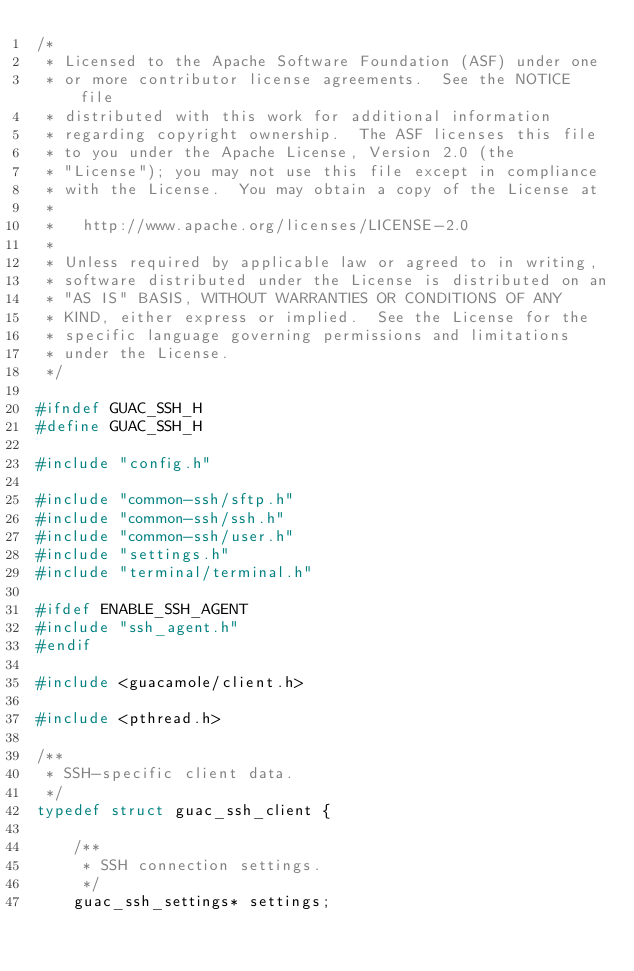Convert code to text. <code><loc_0><loc_0><loc_500><loc_500><_C_>/*
 * Licensed to the Apache Software Foundation (ASF) under one
 * or more contributor license agreements.  See the NOTICE file
 * distributed with this work for additional information
 * regarding copyright ownership.  The ASF licenses this file
 * to you under the Apache License, Version 2.0 (the
 * "License"); you may not use this file except in compliance
 * with the License.  You may obtain a copy of the License at
 *
 *   http://www.apache.org/licenses/LICENSE-2.0
 *
 * Unless required by applicable law or agreed to in writing,
 * software distributed under the License is distributed on an
 * "AS IS" BASIS, WITHOUT WARRANTIES OR CONDITIONS OF ANY
 * KIND, either express or implied.  See the License for the
 * specific language governing permissions and limitations
 * under the License.
 */

#ifndef GUAC_SSH_H
#define GUAC_SSH_H

#include "config.h"

#include "common-ssh/sftp.h"
#include "common-ssh/ssh.h"
#include "common-ssh/user.h"
#include "settings.h"
#include "terminal/terminal.h"

#ifdef ENABLE_SSH_AGENT
#include "ssh_agent.h"
#endif

#include <guacamole/client.h>

#include <pthread.h>

/**
 * SSH-specific client data.
 */
typedef struct guac_ssh_client {

    /**
     * SSH connection settings.
     */
    guac_ssh_settings* settings;
</code> 